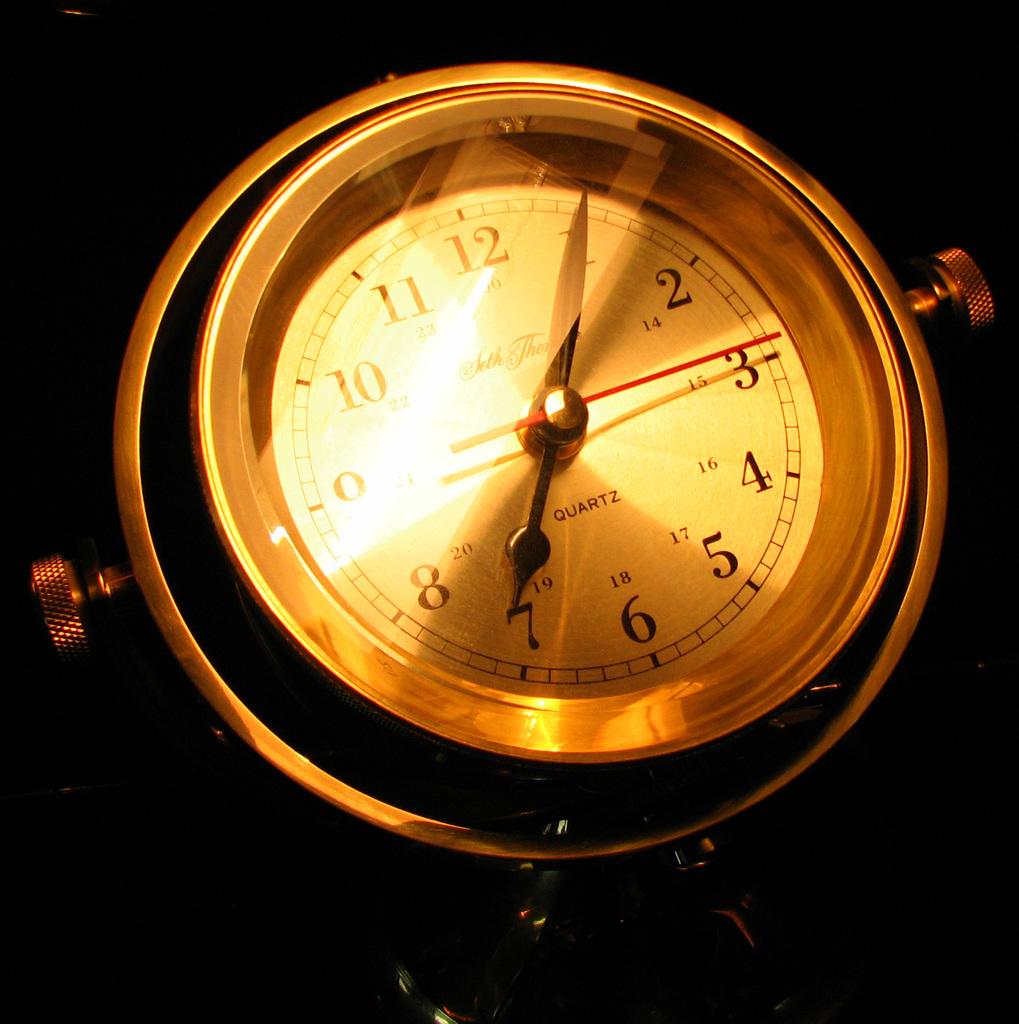What is this watch made of?
Your answer should be very brief. Quartz. What is the minute hand pointing to?
Your answer should be very brief. 3. 